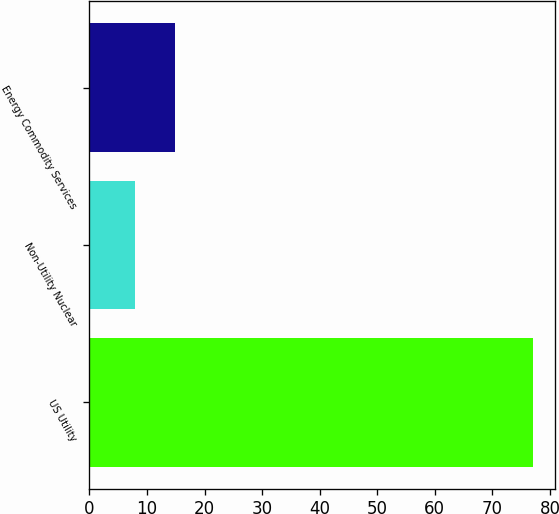<chart> <loc_0><loc_0><loc_500><loc_500><bar_chart><fcel>US Utility<fcel>Non-Utility Nuclear<fcel>Energy Commodity Services<nl><fcel>77<fcel>8<fcel>14.9<nl></chart> 